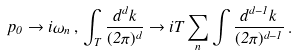<formula> <loc_0><loc_0><loc_500><loc_500>p _ { 0 } \rightarrow i \omega _ { n } \, , \, \int _ { T } \frac { d ^ { d } k } { ( 2 \pi ) ^ { d } } \rightarrow i T \sum _ { n } \int \frac { d ^ { d - 1 } { k } } { ( 2 \pi ) ^ { d - 1 } } \, .</formula> 